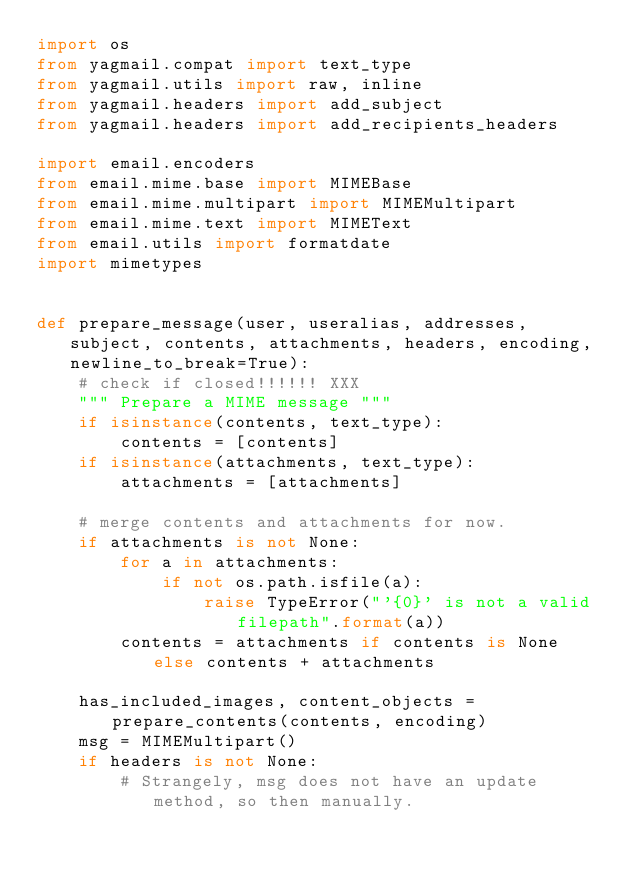<code> <loc_0><loc_0><loc_500><loc_500><_Python_>import os
from yagmail.compat import text_type
from yagmail.utils import raw, inline
from yagmail.headers import add_subject
from yagmail.headers import add_recipients_headers

import email.encoders
from email.mime.base import MIMEBase
from email.mime.multipart import MIMEMultipart
from email.mime.text import MIMEText
from email.utils import formatdate
import mimetypes


def prepare_message(user, useralias, addresses, subject, contents, attachments, headers, encoding, newline_to_break=True):
    # check if closed!!!!!! XXX
    """ Prepare a MIME message """
    if isinstance(contents, text_type):
        contents = [contents]
    if isinstance(attachments, text_type):
        attachments = [attachments]

    # merge contents and attachments for now.
    if attachments is not None:
        for a in attachments:
            if not os.path.isfile(a):
                raise TypeError("'{0}' is not a valid filepath".format(a))
        contents = attachments if contents is None else contents + attachments

    has_included_images, content_objects = prepare_contents(contents, encoding)
    msg = MIMEMultipart()
    if headers is not None:
        # Strangely, msg does not have an update method, so then manually.</code> 